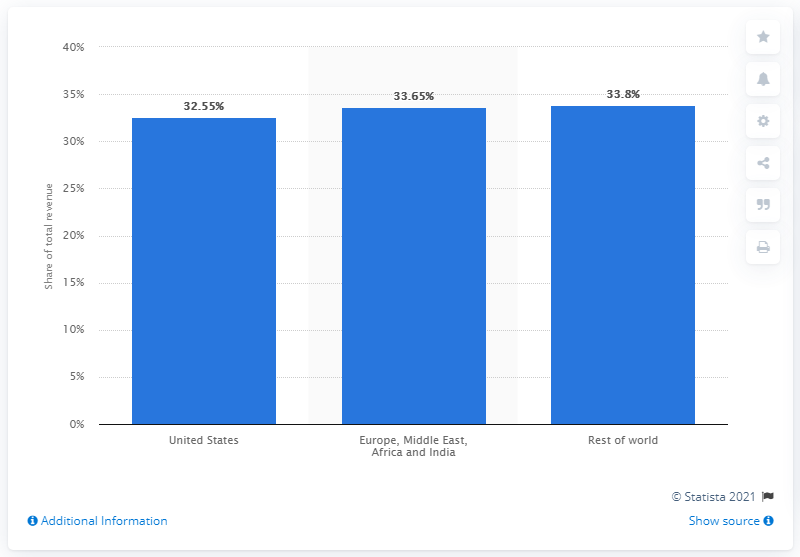Give some essential details in this illustration. In 2020, Dow's revenue generated in the United States was approximately 32.55%. 